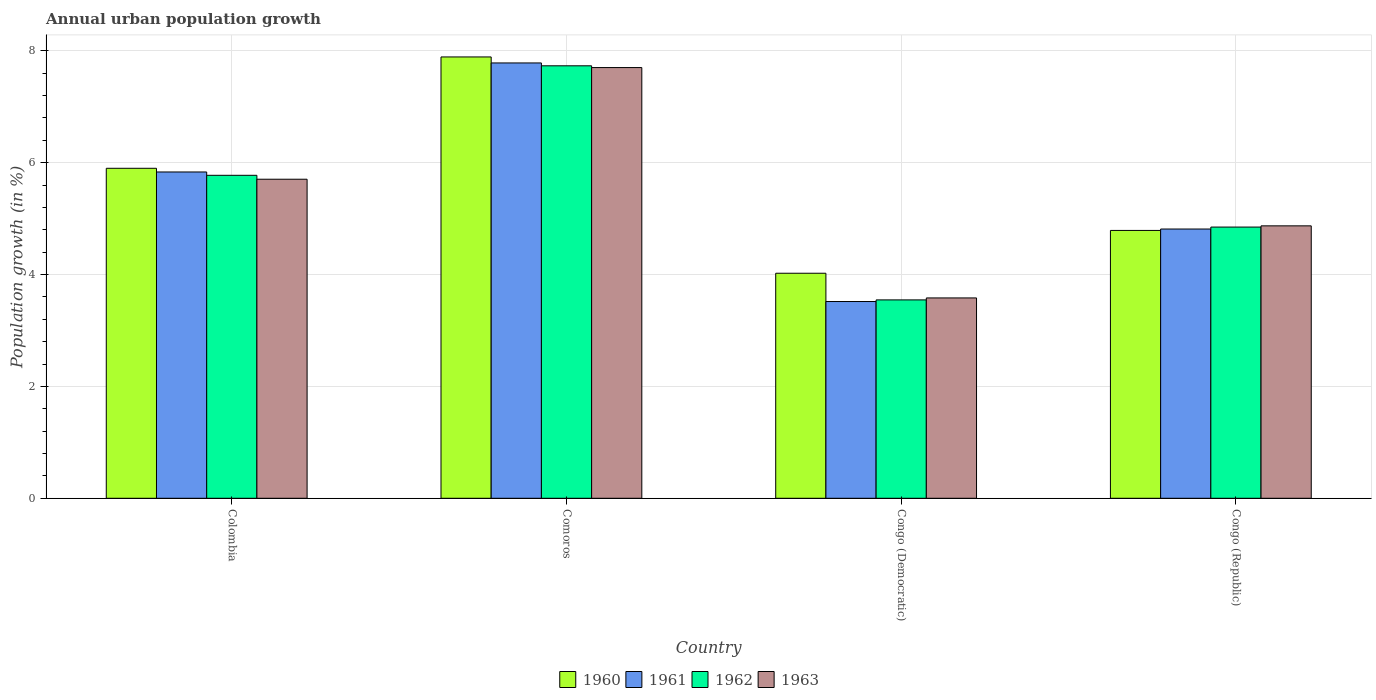Are the number of bars per tick equal to the number of legend labels?
Give a very brief answer. Yes. What is the label of the 2nd group of bars from the left?
Offer a very short reply. Comoros. What is the percentage of urban population growth in 1963 in Comoros?
Make the answer very short. 7.7. Across all countries, what is the maximum percentage of urban population growth in 1961?
Keep it short and to the point. 7.78. Across all countries, what is the minimum percentage of urban population growth in 1960?
Give a very brief answer. 4.02. In which country was the percentage of urban population growth in 1963 maximum?
Keep it short and to the point. Comoros. In which country was the percentage of urban population growth in 1963 minimum?
Provide a short and direct response. Congo (Democratic). What is the total percentage of urban population growth in 1963 in the graph?
Keep it short and to the point. 21.85. What is the difference between the percentage of urban population growth in 1960 in Congo (Democratic) and that in Congo (Republic)?
Make the answer very short. -0.77. What is the difference between the percentage of urban population growth in 1961 in Comoros and the percentage of urban population growth in 1962 in Congo (Democratic)?
Your response must be concise. 4.24. What is the average percentage of urban population growth in 1963 per country?
Offer a terse response. 5.46. What is the difference between the percentage of urban population growth of/in 1962 and percentage of urban population growth of/in 1963 in Colombia?
Your answer should be very brief. 0.07. What is the ratio of the percentage of urban population growth in 1963 in Comoros to that in Congo (Democratic)?
Provide a succinct answer. 2.15. Is the percentage of urban population growth in 1963 in Colombia less than that in Congo (Democratic)?
Offer a terse response. No. What is the difference between the highest and the second highest percentage of urban population growth in 1962?
Offer a very short reply. -0.93. What is the difference between the highest and the lowest percentage of urban population growth in 1961?
Provide a succinct answer. 4.26. Is it the case that in every country, the sum of the percentage of urban population growth in 1963 and percentage of urban population growth in 1960 is greater than the sum of percentage of urban population growth in 1961 and percentage of urban population growth in 1962?
Your answer should be very brief. No. What does the 3rd bar from the right in Colombia represents?
Your answer should be compact. 1961. Is it the case that in every country, the sum of the percentage of urban population growth in 1961 and percentage of urban population growth in 1963 is greater than the percentage of urban population growth in 1960?
Your answer should be very brief. Yes. Are all the bars in the graph horizontal?
Make the answer very short. No. How many countries are there in the graph?
Your answer should be very brief. 4. What is the difference between two consecutive major ticks on the Y-axis?
Your answer should be very brief. 2. Does the graph contain any zero values?
Offer a terse response. No. Does the graph contain grids?
Provide a short and direct response. Yes. How many legend labels are there?
Provide a short and direct response. 4. What is the title of the graph?
Offer a terse response. Annual urban population growth. What is the label or title of the X-axis?
Ensure brevity in your answer.  Country. What is the label or title of the Y-axis?
Give a very brief answer. Population growth (in %). What is the Population growth (in %) in 1960 in Colombia?
Provide a succinct answer. 5.9. What is the Population growth (in %) in 1961 in Colombia?
Give a very brief answer. 5.83. What is the Population growth (in %) in 1962 in Colombia?
Offer a very short reply. 5.77. What is the Population growth (in %) of 1963 in Colombia?
Your answer should be very brief. 5.7. What is the Population growth (in %) in 1960 in Comoros?
Provide a short and direct response. 7.89. What is the Population growth (in %) in 1961 in Comoros?
Give a very brief answer. 7.78. What is the Population growth (in %) of 1962 in Comoros?
Your answer should be compact. 7.73. What is the Population growth (in %) of 1963 in Comoros?
Your answer should be compact. 7.7. What is the Population growth (in %) of 1960 in Congo (Democratic)?
Offer a very short reply. 4.02. What is the Population growth (in %) in 1961 in Congo (Democratic)?
Your response must be concise. 3.52. What is the Population growth (in %) in 1962 in Congo (Democratic)?
Provide a short and direct response. 3.55. What is the Population growth (in %) in 1963 in Congo (Democratic)?
Your response must be concise. 3.58. What is the Population growth (in %) of 1960 in Congo (Republic)?
Provide a short and direct response. 4.79. What is the Population growth (in %) in 1961 in Congo (Republic)?
Your answer should be very brief. 4.81. What is the Population growth (in %) of 1962 in Congo (Republic)?
Offer a terse response. 4.85. What is the Population growth (in %) in 1963 in Congo (Republic)?
Your answer should be compact. 4.87. Across all countries, what is the maximum Population growth (in %) of 1960?
Keep it short and to the point. 7.89. Across all countries, what is the maximum Population growth (in %) of 1961?
Ensure brevity in your answer.  7.78. Across all countries, what is the maximum Population growth (in %) of 1962?
Provide a short and direct response. 7.73. Across all countries, what is the maximum Population growth (in %) in 1963?
Make the answer very short. 7.7. Across all countries, what is the minimum Population growth (in %) of 1960?
Give a very brief answer. 4.02. Across all countries, what is the minimum Population growth (in %) of 1961?
Your response must be concise. 3.52. Across all countries, what is the minimum Population growth (in %) of 1962?
Ensure brevity in your answer.  3.55. Across all countries, what is the minimum Population growth (in %) of 1963?
Provide a short and direct response. 3.58. What is the total Population growth (in %) in 1960 in the graph?
Keep it short and to the point. 22.6. What is the total Population growth (in %) of 1961 in the graph?
Provide a short and direct response. 21.95. What is the total Population growth (in %) in 1962 in the graph?
Keep it short and to the point. 21.9. What is the total Population growth (in %) of 1963 in the graph?
Your answer should be very brief. 21.85. What is the difference between the Population growth (in %) of 1960 in Colombia and that in Comoros?
Your response must be concise. -1.99. What is the difference between the Population growth (in %) of 1961 in Colombia and that in Comoros?
Make the answer very short. -1.95. What is the difference between the Population growth (in %) in 1962 in Colombia and that in Comoros?
Offer a terse response. -1.96. What is the difference between the Population growth (in %) in 1963 in Colombia and that in Comoros?
Your answer should be very brief. -2. What is the difference between the Population growth (in %) of 1960 in Colombia and that in Congo (Democratic)?
Provide a short and direct response. 1.88. What is the difference between the Population growth (in %) in 1961 in Colombia and that in Congo (Democratic)?
Provide a short and direct response. 2.32. What is the difference between the Population growth (in %) of 1962 in Colombia and that in Congo (Democratic)?
Ensure brevity in your answer.  2.23. What is the difference between the Population growth (in %) in 1963 in Colombia and that in Congo (Democratic)?
Make the answer very short. 2.12. What is the difference between the Population growth (in %) in 1960 in Colombia and that in Congo (Republic)?
Give a very brief answer. 1.11. What is the difference between the Population growth (in %) in 1961 in Colombia and that in Congo (Republic)?
Offer a terse response. 1.02. What is the difference between the Population growth (in %) in 1962 in Colombia and that in Congo (Republic)?
Your answer should be very brief. 0.93. What is the difference between the Population growth (in %) in 1963 in Colombia and that in Congo (Republic)?
Ensure brevity in your answer.  0.83. What is the difference between the Population growth (in %) of 1960 in Comoros and that in Congo (Democratic)?
Keep it short and to the point. 3.87. What is the difference between the Population growth (in %) of 1961 in Comoros and that in Congo (Democratic)?
Provide a succinct answer. 4.26. What is the difference between the Population growth (in %) of 1962 in Comoros and that in Congo (Democratic)?
Give a very brief answer. 4.18. What is the difference between the Population growth (in %) of 1963 in Comoros and that in Congo (Democratic)?
Keep it short and to the point. 4.12. What is the difference between the Population growth (in %) in 1960 in Comoros and that in Congo (Republic)?
Offer a very short reply. 3.1. What is the difference between the Population growth (in %) in 1961 in Comoros and that in Congo (Republic)?
Your answer should be very brief. 2.97. What is the difference between the Population growth (in %) in 1962 in Comoros and that in Congo (Republic)?
Keep it short and to the point. 2.88. What is the difference between the Population growth (in %) of 1963 in Comoros and that in Congo (Republic)?
Ensure brevity in your answer.  2.83. What is the difference between the Population growth (in %) in 1960 in Congo (Democratic) and that in Congo (Republic)?
Offer a very short reply. -0.77. What is the difference between the Population growth (in %) in 1961 in Congo (Democratic) and that in Congo (Republic)?
Offer a terse response. -1.3. What is the difference between the Population growth (in %) in 1962 in Congo (Democratic) and that in Congo (Republic)?
Give a very brief answer. -1.3. What is the difference between the Population growth (in %) in 1963 in Congo (Democratic) and that in Congo (Republic)?
Make the answer very short. -1.29. What is the difference between the Population growth (in %) in 1960 in Colombia and the Population growth (in %) in 1961 in Comoros?
Your answer should be very brief. -1.88. What is the difference between the Population growth (in %) of 1960 in Colombia and the Population growth (in %) of 1962 in Comoros?
Your answer should be compact. -1.83. What is the difference between the Population growth (in %) in 1960 in Colombia and the Population growth (in %) in 1963 in Comoros?
Your response must be concise. -1.8. What is the difference between the Population growth (in %) in 1961 in Colombia and the Population growth (in %) in 1962 in Comoros?
Give a very brief answer. -1.9. What is the difference between the Population growth (in %) in 1961 in Colombia and the Population growth (in %) in 1963 in Comoros?
Keep it short and to the point. -1.87. What is the difference between the Population growth (in %) of 1962 in Colombia and the Population growth (in %) of 1963 in Comoros?
Keep it short and to the point. -1.93. What is the difference between the Population growth (in %) in 1960 in Colombia and the Population growth (in %) in 1961 in Congo (Democratic)?
Offer a very short reply. 2.38. What is the difference between the Population growth (in %) in 1960 in Colombia and the Population growth (in %) in 1962 in Congo (Democratic)?
Offer a very short reply. 2.35. What is the difference between the Population growth (in %) of 1960 in Colombia and the Population growth (in %) of 1963 in Congo (Democratic)?
Your answer should be very brief. 2.32. What is the difference between the Population growth (in %) in 1961 in Colombia and the Population growth (in %) in 1962 in Congo (Democratic)?
Provide a succinct answer. 2.29. What is the difference between the Population growth (in %) in 1961 in Colombia and the Population growth (in %) in 1963 in Congo (Democratic)?
Give a very brief answer. 2.25. What is the difference between the Population growth (in %) of 1962 in Colombia and the Population growth (in %) of 1963 in Congo (Democratic)?
Make the answer very short. 2.19. What is the difference between the Population growth (in %) of 1960 in Colombia and the Population growth (in %) of 1961 in Congo (Republic)?
Your answer should be very brief. 1.09. What is the difference between the Population growth (in %) in 1960 in Colombia and the Population growth (in %) in 1962 in Congo (Republic)?
Give a very brief answer. 1.05. What is the difference between the Population growth (in %) in 1960 in Colombia and the Population growth (in %) in 1963 in Congo (Republic)?
Offer a terse response. 1.03. What is the difference between the Population growth (in %) in 1961 in Colombia and the Population growth (in %) in 1962 in Congo (Republic)?
Offer a very short reply. 0.98. What is the difference between the Population growth (in %) in 1961 in Colombia and the Population growth (in %) in 1963 in Congo (Republic)?
Your response must be concise. 0.96. What is the difference between the Population growth (in %) in 1962 in Colombia and the Population growth (in %) in 1963 in Congo (Republic)?
Offer a very short reply. 0.9. What is the difference between the Population growth (in %) of 1960 in Comoros and the Population growth (in %) of 1961 in Congo (Democratic)?
Your response must be concise. 4.37. What is the difference between the Population growth (in %) in 1960 in Comoros and the Population growth (in %) in 1962 in Congo (Democratic)?
Your answer should be very brief. 4.34. What is the difference between the Population growth (in %) of 1960 in Comoros and the Population growth (in %) of 1963 in Congo (Democratic)?
Provide a short and direct response. 4.31. What is the difference between the Population growth (in %) in 1961 in Comoros and the Population growth (in %) in 1962 in Congo (Democratic)?
Provide a short and direct response. 4.24. What is the difference between the Population growth (in %) of 1961 in Comoros and the Population growth (in %) of 1963 in Congo (Democratic)?
Ensure brevity in your answer.  4.2. What is the difference between the Population growth (in %) in 1962 in Comoros and the Population growth (in %) in 1963 in Congo (Democratic)?
Offer a terse response. 4.15. What is the difference between the Population growth (in %) of 1960 in Comoros and the Population growth (in %) of 1961 in Congo (Republic)?
Your response must be concise. 3.08. What is the difference between the Population growth (in %) of 1960 in Comoros and the Population growth (in %) of 1962 in Congo (Republic)?
Keep it short and to the point. 3.04. What is the difference between the Population growth (in %) in 1960 in Comoros and the Population growth (in %) in 1963 in Congo (Republic)?
Give a very brief answer. 3.02. What is the difference between the Population growth (in %) in 1961 in Comoros and the Population growth (in %) in 1962 in Congo (Republic)?
Give a very brief answer. 2.93. What is the difference between the Population growth (in %) in 1961 in Comoros and the Population growth (in %) in 1963 in Congo (Republic)?
Ensure brevity in your answer.  2.91. What is the difference between the Population growth (in %) of 1962 in Comoros and the Population growth (in %) of 1963 in Congo (Republic)?
Your response must be concise. 2.86. What is the difference between the Population growth (in %) of 1960 in Congo (Democratic) and the Population growth (in %) of 1961 in Congo (Republic)?
Give a very brief answer. -0.79. What is the difference between the Population growth (in %) of 1960 in Congo (Democratic) and the Population growth (in %) of 1962 in Congo (Republic)?
Make the answer very short. -0.83. What is the difference between the Population growth (in %) in 1960 in Congo (Democratic) and the Population growth (in %) in 1963 in Congo (Republic)?
Provide a short and direct response. -0.85. What is the difference between the Population growth (in %) in 1961 in Congo (Democratic) and the Population growth (in %) in 1962 in Congo (Republic)?
Make the answer very short. -1.33. What is the difference between the Population growth (in %) of 1961 in Congo (Democratic) and the Population growth (in %) of 1963 in Congo (Republic)?
Give a very brief answer. -1.35. What is the difference between the Population growth (in %) of 1962 in Congo (Democratic) and the Population growth (in %) of 1963 in Congo (Republic)?
Keep it short and to the point. -1.32. What is the average Population growth (in %) of 1960 per country?
Provide a succinct answer. 5.65. What is the average Population growth (in %) in 1961 per country?
Your answer should be very brief. 5.49. What is the average Population growth (in %) in 1962 per country?
Your answer should be very brief. 5.47. What is the average Population growth (in %) in 1963 per country?
Your response must be concise. 5.46. What is the difference between the Population growth (in %) of 1960 and Population growth (in %) of 1961 in Colombia?
Ensure brevity in your answer.  0.07. What is the difference between the Population growth (in %) of 1960 and Population growth (in %) of 1962 in Colombia?
Offer a terse response. 0.13. What is the difference between the Population growth (in %) in 1960 and Population growth (in %) in 1963 in Colombia?
Ensure brevity in your answer.  0.2. What is the difference between the Population growth (in %) in 1961 and Population growth (in %) in 1962 in Colombia?
Your answer should be very brief. 0.06. What is the difference between the Population growth (in %) of 1961 and Population growth (in %) of 1963 in Colombia?
Offer a very short reply. 0.13. What is the difference between the Population growth (in %) of 1962 and Population growth (in %) of 1963 in Colombia?
Offer a terse response. 0.07. What is the difference between the Population growth (in %) of 1960 and Population growth (in %) of 1961 in Comoros?
Keep it short and to the point. 0.11. What is the difference between the Population growth (in %) of 1960 and Population growth (in %) of 1962 in Comoros?
Offer a terse response. 0.16. What is the difference between the Population growth (in %) in 1960 and Population growth (in %) in 1963 in Comoros?
Give a very brief answer. 0.19. What is the difference between the Population growth (in %) of 1961 and Population growth (in %) of 1962 in Comoros?
Make the answer very short. 0.05. What is the difference between the Population growth (in %) of 1961 and Population growth (in %) of 1963 in Comoros?
Provide a short and direct response. 0.08. What is the difference between the Population growth (in %) of 1962 and Population growth (in %) of 1963 in Comoros?
Provide a short and direct response. 0.03. What is the difference between the Population growth (in %) of 1960 and Population growth (in %) of 1961 in Congo (Democratic)?
Keep it short and to the point. 0.51. What is the difference between the Population growth (in %) in 1960 and Population growth (in %) in 1962 in Congo (Democratic)?
Ensure brevity in your answer.  0.48. What is the difference between the Population growth (in %) of 1960 and Population growth (in %) of 1963 in Congo (Democratic)?
Ensure brevity in your answer.  0.44. What is the difference between the Population growth (in %) of 1961 and Population growth (in %) of 1962 in Congo (Democratic)?
Offer a terse response. -0.03. What is the difference between the Population growth (in %) of 1961 and Population growth (in %) of 1963 in Congo (Democratic)?
Your answer should be compact. -0.06. What is the difference between the Population growth (in %) in 1962 and Population growth (in %) in 1963 in Congo (Democratic)?
Offer a terse response. -0.04. What is the difference between the Population growth (in %) in 1960 and Population growth (in %) in 1961 in Congo (Republic)?
Your answer should be very brief. -0.03. What is the difference between the Population growth (in %) of 1960 and Population growth (in %) of 1962 in Congo (Republic)?
Offer a terse response. -0.06. What is the difference between the Population growth (in %) of 1960 and Population growth (in %) of 1963 in Congo (Republic)?
Make the answer very short. -0.08. What is the difference between the Population growth (in %) in 1961 and Population growth (in %) in 1962 in Congo (Republic)?
Provide a short and direct response. -0.03. What is the difference between the Population growth (in %) of 1961 and Population growth (in %) of 1963 in Congo (Republic)?
Keep it short and to the point. -0.06. What is the difference between the Population growth (in %) in 1962 and Population growth (in %) in 1963 in Congo (Republic)?
Offer a terse response. -0.02. What is the ratio of the Population growth (in %) in 1960 in Colombia to that in Comoros?
Make the answer very short. 0.75. What is the ratio of the Population growth (in %) of 1961 in Colombia to that in Comoros?
Ensure brevity in your answer.  0.75. What is the ratio of the Population growth (in %) in 1962 in Colombia to that in Comoros?
Ensure brevity in your answer.  0.75. What is the ratio of the Population growth (in %) of 1963 in Colombia to that in Comoros?
Give a very brief answer. 0.74. What is the ratio of the Population growth (in %) of 1960 in Colombia to that in Congo (Democratic)?
Offer a terse response. 1.47. What is the ratio of the Population growth (in %) in 1961 in Colombia to that in Congo (Democratic)?
Your answer should be compact. 1.66. What is the ratio of the Population growth (in %) in 1962 in Colombia to that in Congo (Democratic)?
Your answer should be compact. 1.63. What is the ratio of the Population growth (in %) in 1963 in Colombia to that in Congo (Democratic)?
Your answer should be compact. 1.59. What is the ratio of the Population growth (in %) in 1960 in Colombia to that in Congo (Republic)?
Keep it short and to the point. 1.23. What is the ratio of the Population growth (in %) in 1961 in Colombia to that in Congo (Republic)?
Ensure brevity in your answer.  1.21. What is the ratio of the Population growth (in %) in 1962 in Colombia to that in Congo (Republic)?
Provide a succinct answer. 1.19. What is the ratio of the Population growth (in %) in 1963 in Colombia to that in Congo (Republic)?
Keep it short and to the point. 1.17. What is the ratio of the Population growth (in %) of 1960 in Comoros to that in Congo (Democratic)?
Give a very brief answer. 1.96. What is the ratio of the Population growth (in %) of 1961 in Comoros to that in Congo (Democratic)?
Offer a terse response. 2.21. What is the ratio of the Population growth (in %) in 1962 in Comoros to that in Congo (Democratic)?
Your answer should be very brief. 2.18. What is the ratio of the Population growth (in %) of 1963 in Comoros to that in Congo (Democratic)?
Your response must be concise. 2.15. What is the ratio of the Population growth (in %) in 1960 in Comoros to that in Congo (Republic)?
Provide a succinct answer. 1.65. What is the ratio of the Population growth (in %) of 1961 in Comoros to that in Congo (Republic)?
Make the answer very short. 1.62. What is the ratio of the Population growth (in %) in 1962 in Comoros to that in Congo (Republic)?
Offer a terse response. 1.59. What is the ratio of the Population growth (in %) in 1963 in Comoros to that in Congo (Republic)?
Keep it short and to the point. 1.58. What is the ratio of the Population growth (in %) in 1960 in Congo (Democratic) to that in Congo (Republic)?
Offer a terse response. 0.84. What is the ratio of the Population growth (in %) of 1961 in Congo (Democratic) to that in Congo (Republic)?
Provide a succinct answer. 0.73. What is the ratio of the Population growth (in %) in 1962 in Congo (Democratic) to that in Congo (Republic)?
Your response must be concise. 0.73. What is the ratio of the Population growth (in %) in 1963 in Congo (Democratic) to that in Congo (Republic)?
Ensure brevity in your answer.  0.74. What is the difference between the highest and the second highest Population growth (in %) of 1960?
Your response must be concise. 1.99. What is the difference between the highest and the second highest Population growth (in %) in 1961?
Provide a short and direct response. 1.95. What is the difference between the highest and the second highest Population growth (in %) of 1962?
Offer a very short reply. 1.96. What is the difference between the highest and the second highest Population growth (in %) of 1963?
Make the answer very short. 2. What is the difference between the highest and the lowest Population growth (in %) in 1960?
Provide a short and direct response. 3.87. What is the difference between the highest and the lowest Population growth (in %) of 1961?
Your answer should be compact. 4.26. What is the difference between the highest and the lowest Population growth (in %) of 1962?
Keep it short and to the point. 4.18. What is the difference between the highest and the lowest Population growth (in %) of 1963?
Offer a terse response. 4.12. 